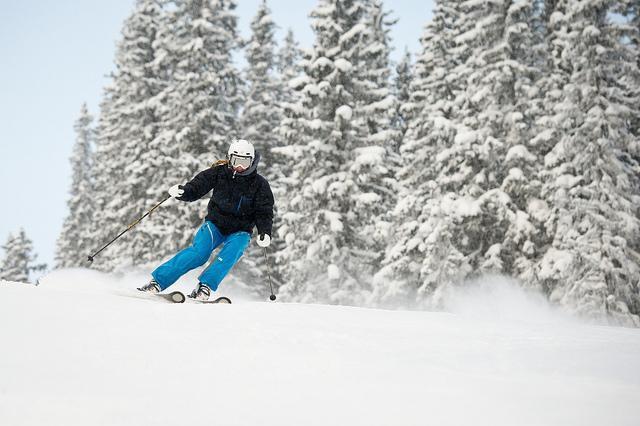How many giraffes are pictured?
Give a very brief answer. 0. 